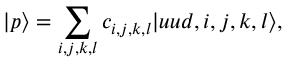Convert formula to latex. <formula><loc_0><loc_0><loc_500><loc_500>| p \rangle = \sum _ { i , j , k , l } c _ { i , j , k , l } | u u d , i , j , k , l \rangle ,</formula> 